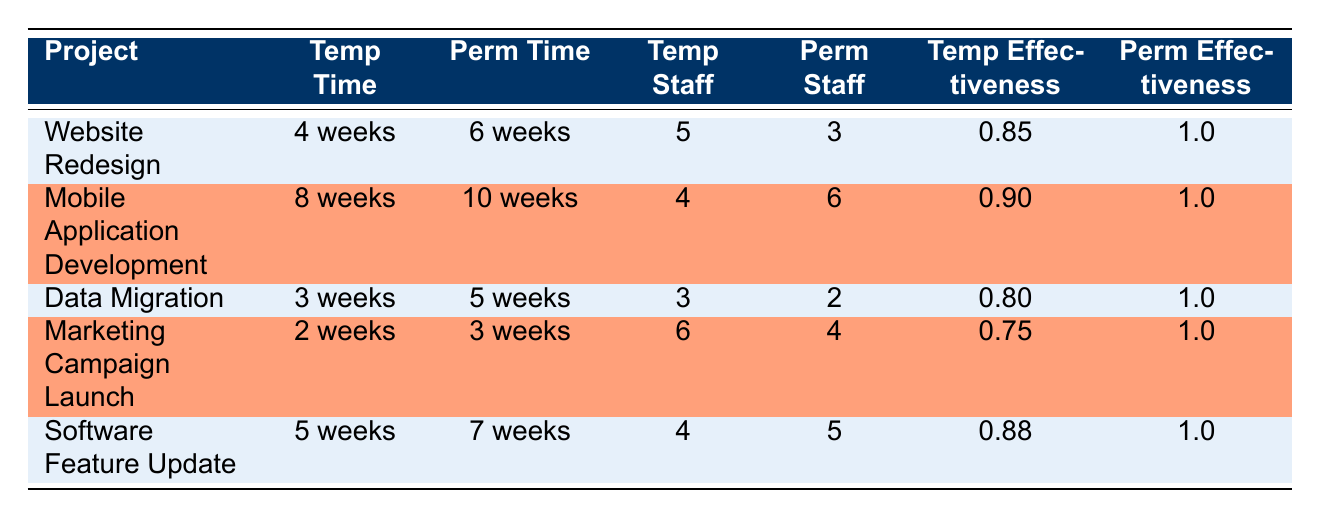What is the completion time for the "Data Migration" project using temporary staff? The table shows that the completion time for the "Data Migration" project using temporary staff is "3 weeks".
Answer: 3 weeks How many temporary staff were assigned to the "Marketing Campaign Launch"? The table indicates that there were "6" temporary staff assigned to the "Marketing Campaign Launch" project.
Answer: 6 Which project had the highest completion time for permanent staff? By examining the completion times for permanent staff, the "Mobile Application Development" project with "10 weeks" stands out as the longest.
Answer: Mobile Application Development What is the total number of staff (temporary and permanent) for the "Website Redesign" project? The total staff for the "Website Redesign" project is the sum of temporary staff (5) and permanent staff (3), which is 5 + 3 = 8.
Answer: 8 Is the effectiveness ratio of permanent staff ever less than that of temporary staff in the table? The table shows that the effectiveness ratio for permanent staff is always 1.0, which is higher than the effectiveness ratios for temporary staff, so the statement is true.
Answer: No What is the average completion time of temporary staff across all projects? To find the average completion time, add the temporary completion times: 4 + 8 + 3 + 2 + 5 = 22 weeks. There are 5 projects, so the average is 22 / 5 = 4.4 weeks.
Answer: 4.4 weeks Which project has the lowest effectiveness ratio for temporary staff? Looking at the effectiveness ratios for temporary staff, the "Marketing Campaign Launch" project has the lowest ratio at 0.75, which is lower than all others listed.
Answer: Marketing Campaign Launch How much faster do temporary staff complete the "Software Feature Update" project compared to permanent staff? The completion time for temporary staff on the project is 5 weeks, while for permanent staff, it is 7 weeks. The difference is 7 - 5 = 2 weeks, indicating temporary staff complete it 2 weeks faster.
Answer: 2 weeks Is it true that temporary staff completed all projects faster than permanent staff? By analyzing the completion times, we see that in each project, the completion time for temporary staff is less than that of permanent staff, confirming the statement is true.
Answer: Yes 